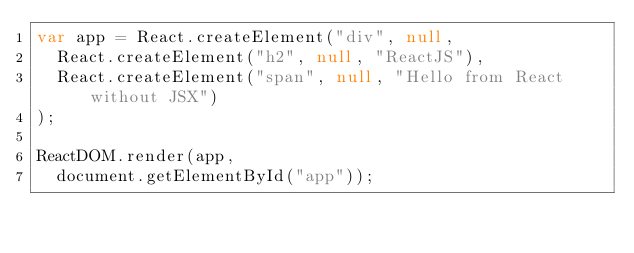Convert code to text. <code><loc_0><loc_0><loc_500><loc_500><_JavaScript_>var app = React.createElement("div", null,
  React.createElement("h2", null, "ReactJS"),
  React.createElement("span", null, "Hello from React without JSX")
);

ReactDOM.render(app, 
  document.getElementById("app"));
</code> 